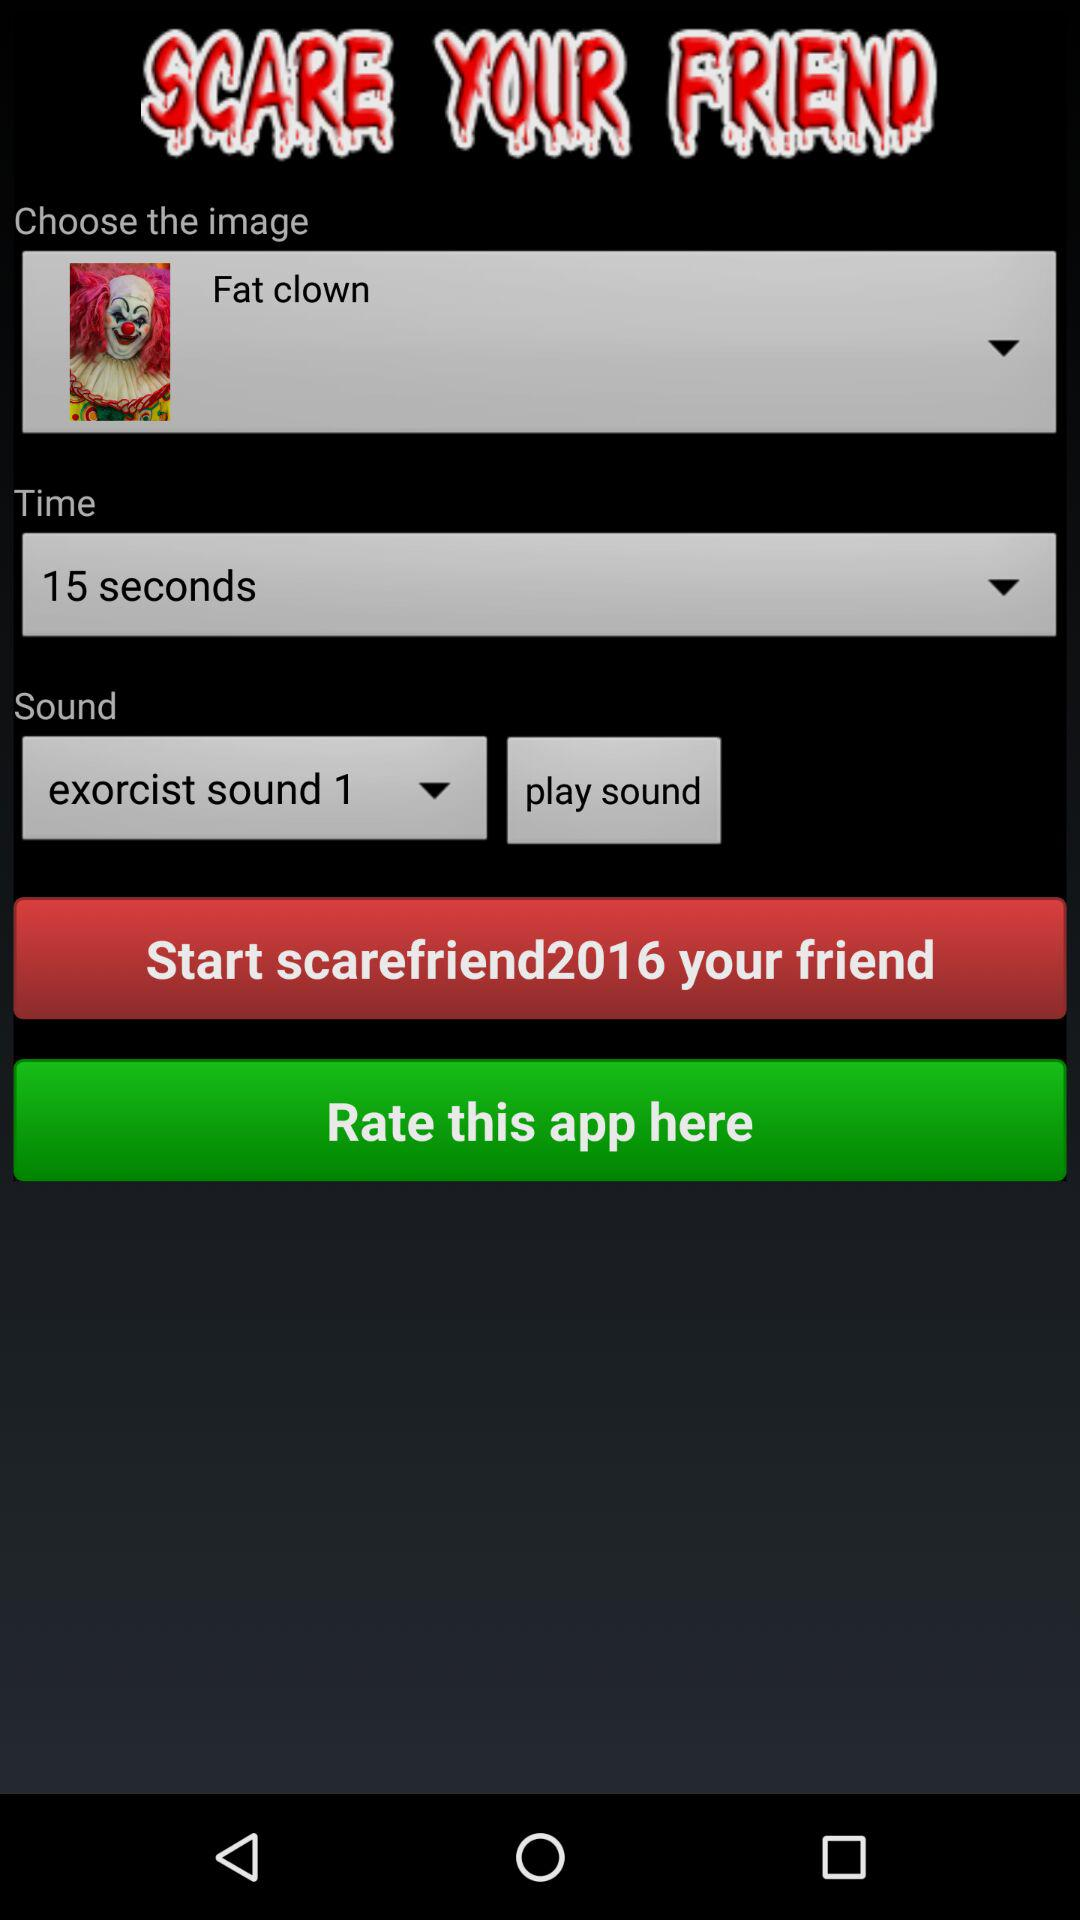Which is the chosen image name? The image name is Fat clown. 